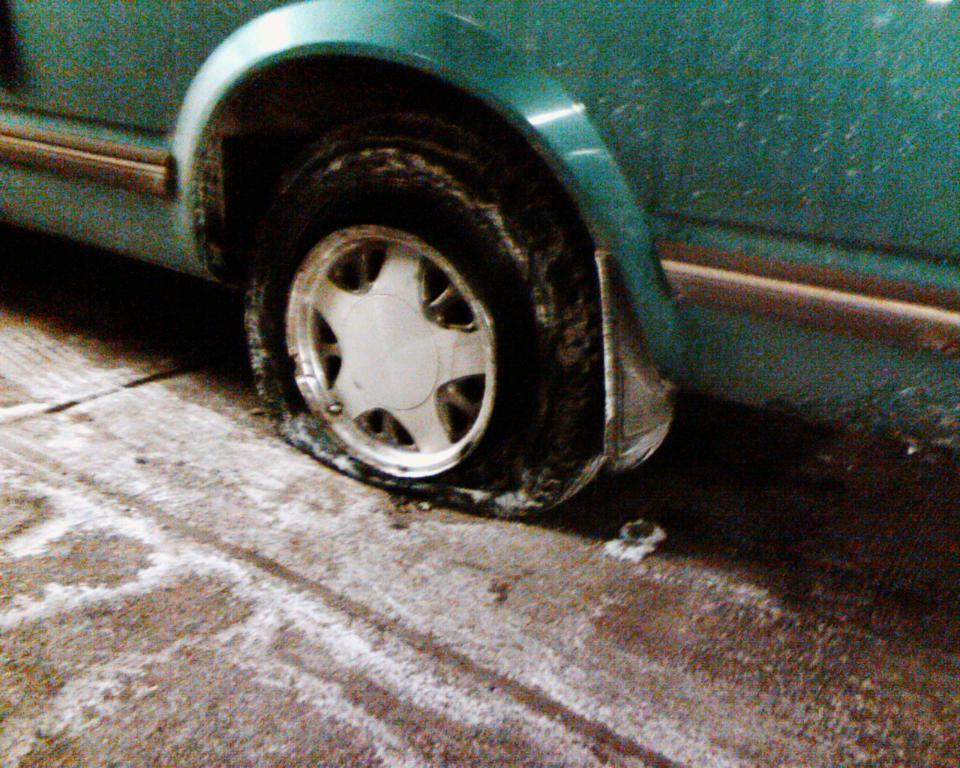What is the main subject of the image? There is a vehicle in the image. What color is the vehicle? The vehicle is green in color. What is the condition of one of the vehicle's tires? The vehicle has a punctured tire. What can be seen at the bottom of the image? The road is visible at the bottom of the image. Is there a notebook on the vehicle's dashboard in the image? There is no mention of a notebook in the image, so we cannot confirm its presence. 